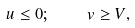<formula> <loc_0><loc_0><loc_500><loc_500>u \leq 0 ; \quad v \geq V ,</formula> 